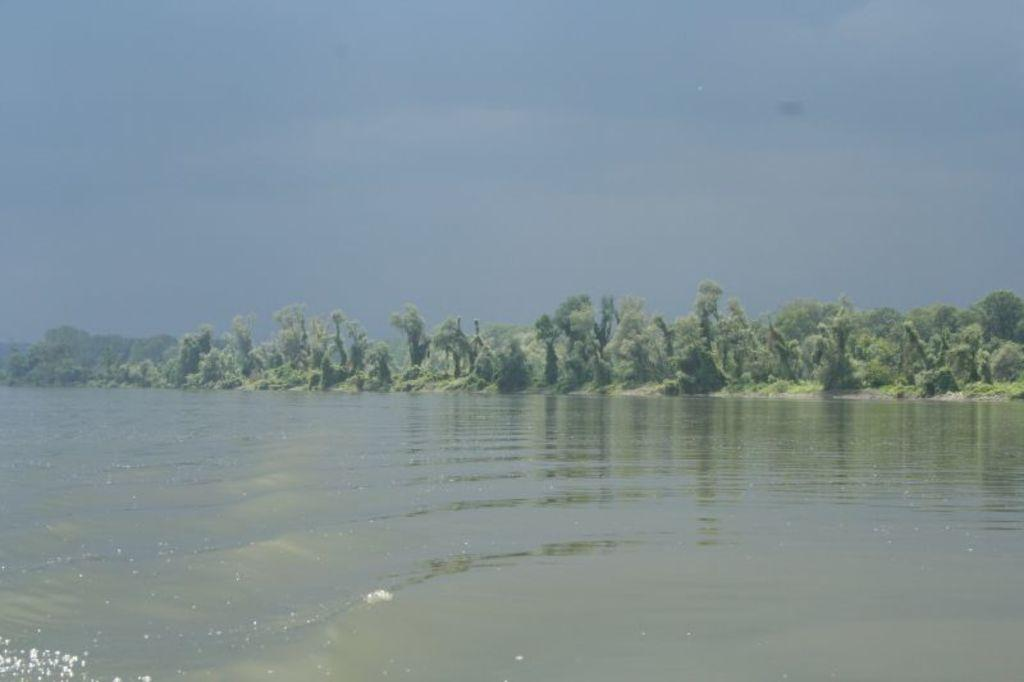What is visible in the image? Water is visible in the image. What can be seen in the background of the image? There are trees in the background of the image. What is visible at the top of the image? The sky is visible at the top of the image. Can you see a ticket floating on the water in the image? There is no ticket visible in the image; only water is present. What type of ink is being used to draw the trees in the background? The image is a photograph, not a drawing, so there is no ink used. 